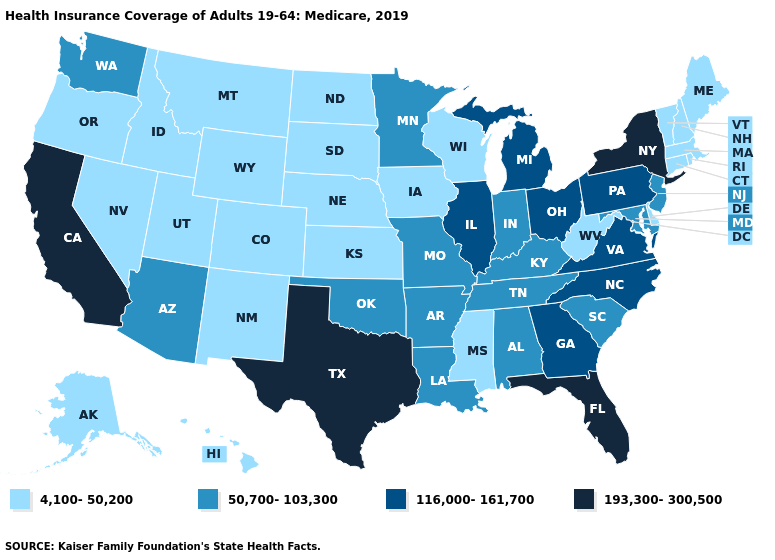Does New Hampshire have the lowest value in the Northeast?
Answer briefly. Yes. What is the value of North Dakota?
Concise answer only. 4,100-50,200. What is the highest value in states that border Virginia?
Concise answer only. 116,000-161,700. Does Hawaii have the lowest value in the USA?
Give a very brief answer. Yes. Which states have the lowest value in the Northeast?
Give a very brief answer. Connecticut, Maine, Massachusetts, New Hampshire, Rhode Island, Vermont. Does Montana have a higher value than New Jersey?
Quick response, please. No. Name the states that have a value in the range 193,300-300,500?
Write a very short answer. California, Florida, New York, Texas. What is the value of Wyoming?
Give a very brief answer. 4,100-50,200. What is the value of Kentucky?
Write a very short answer. 50,700-103,300. Name the states that have a value in the range 50,700-103,300?
Write a very short answer. Alabama, Arizona, Arkansas, Indiana, Kentucky, Louisiana, Maryland, Minnesota, Missouri, New Jersey, Oklahoma, South Carolina, Tennessee, Washington. Name the states that have a value in the range 193,300-300,500?
Concise answer only. California, Florida, New York, Texas. Name the states that have a value in the range 193,300-300,500?
Short answer required. California, Florida, New York, Texas. 